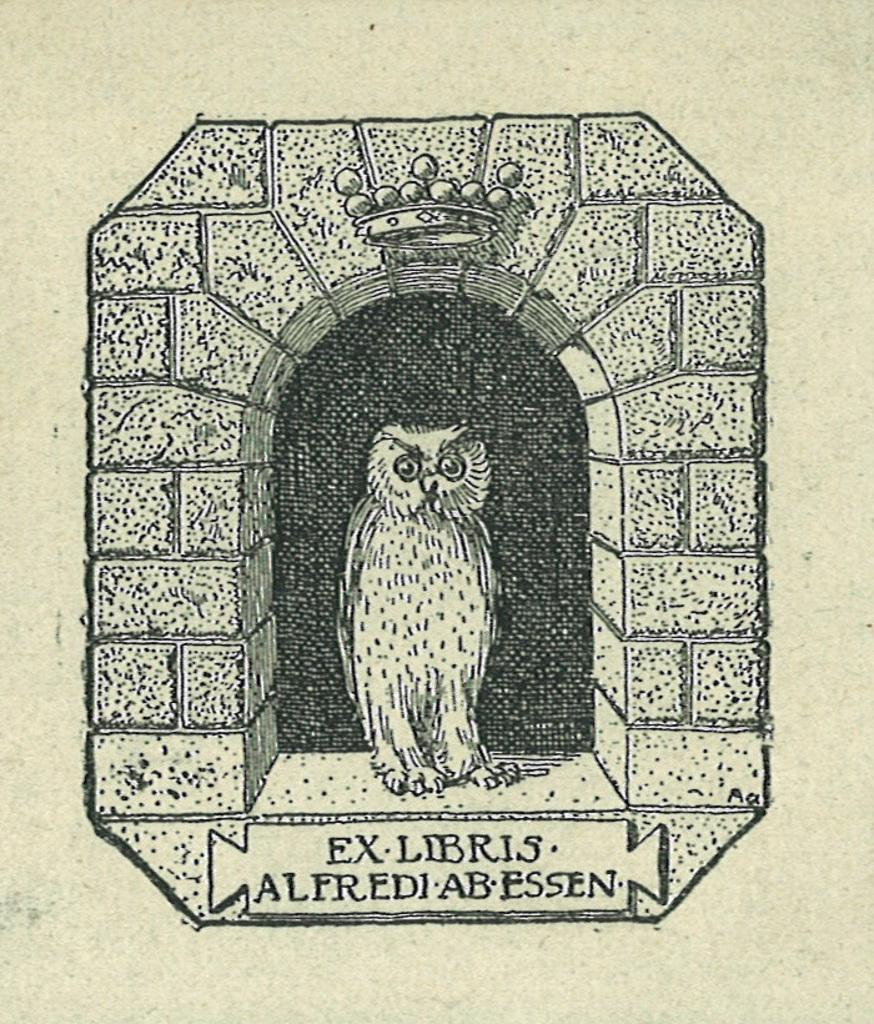What is the main subject of the image? The main subject of the image is a paper. What is depicted on the paper? There is an owl and an arch on the paper. Is there any text present in the image? Yes, there is some text at the bottom of the image. How does the finger interact with the waves in the image? There are no waves or fingers present in the image; it features a paper with an owl, an arch, and some text. 